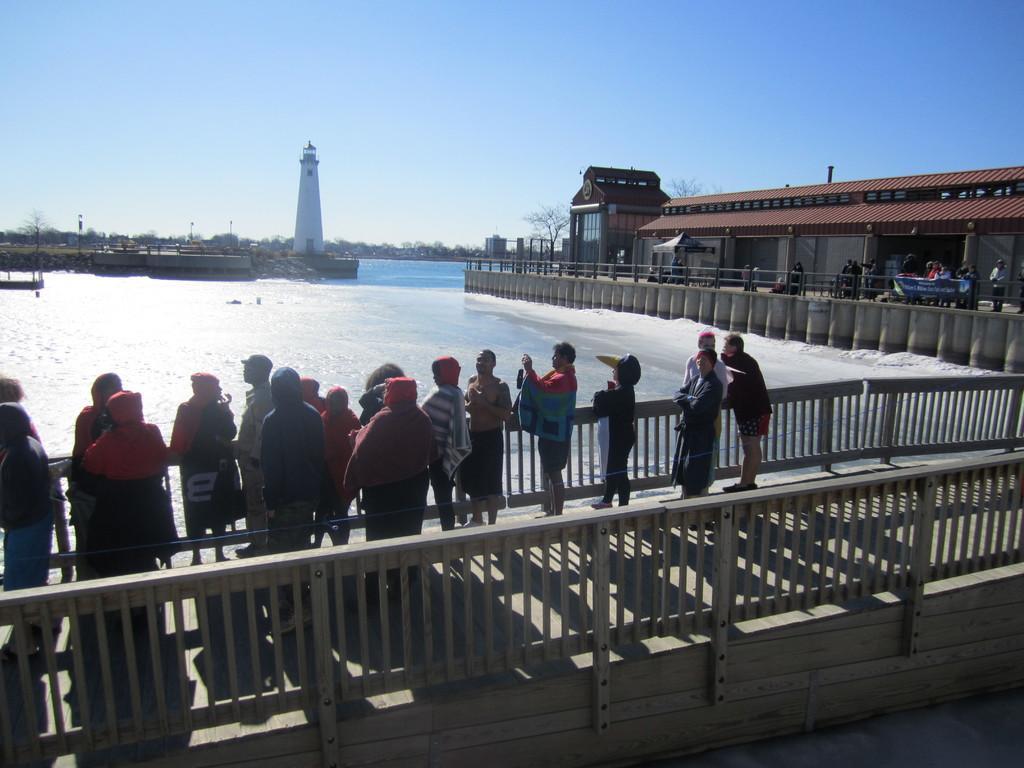Please provide a concise description of this image. In this picture we can see some people are standing in the front, on the right side there is a building, we can see water in the middle, in the background there are trees and a tower, we can see the sky at the top of the picture. 